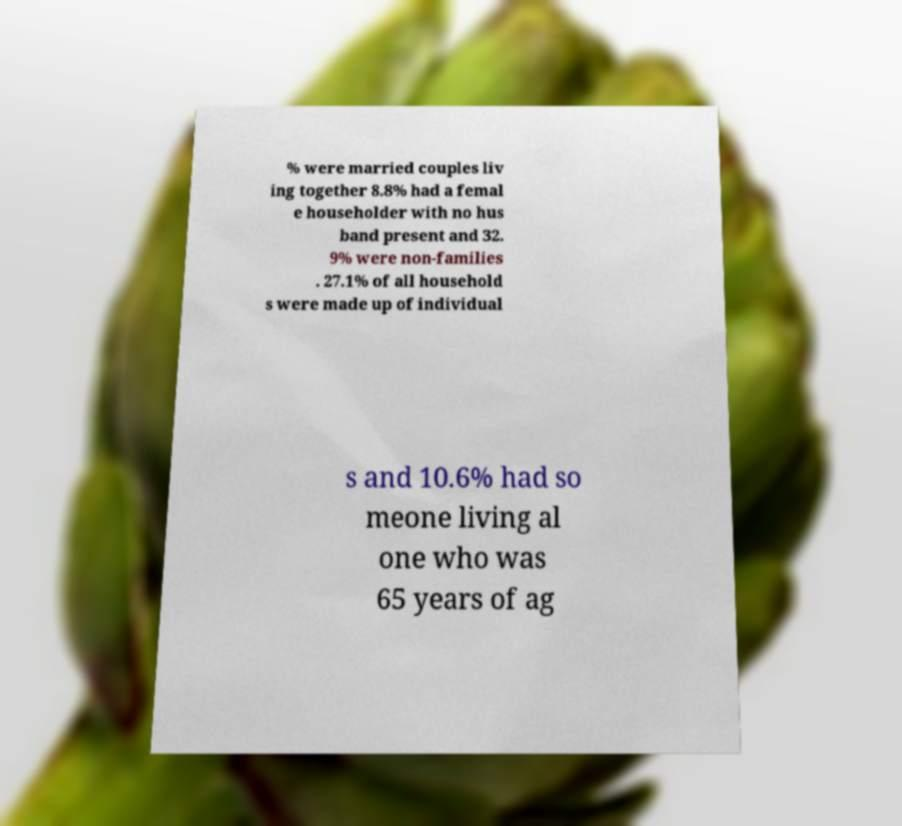Can you accurately transcribe the text from the provided image for me? % were married couples liv ing together 8.8% had a femal e householder with no hus band present and 32. 9% were non-families . 27.1% of all household s were made up of individual s and 10.6% had so meone living al one who was 65 years of ag 